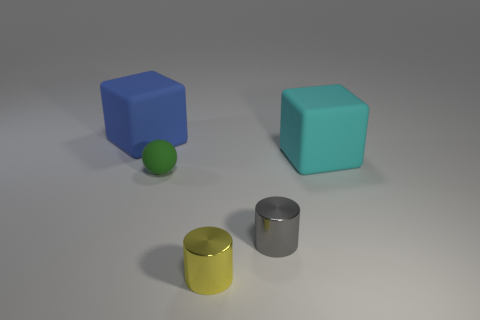Add 3 blue cylinders. How many objects exist? 8 Subtract all cylinders. How many objects are left? 3 Subtract all tiny cyan rubber balls. Subtract all cyan rubber blocks. How many objects are left? 4 Add 2 small yellow cylinders. How many small yellow cylinders are left? 3 Add 3 small metallic things. How many small metallic things exist? 5 Subtract 0 brown blocks. How many objects are left? 5 